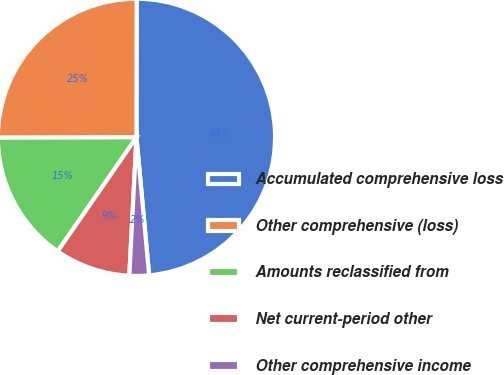Convert chart. <chart><loc_0><loc_0><loc_500><loc_500><pie_chart><fcel>Accumulated comprehensive loss<fcel>Other comprehensive (loss)<fcel>Amounts reclassified from<fcel>Net current-period other<fcel>Other comprehensive income<nl><fcel>48.52%<fcel>25.06%<fcel>15.33%<fcel>8.8%<fcel>2.28%<nl></chart> 